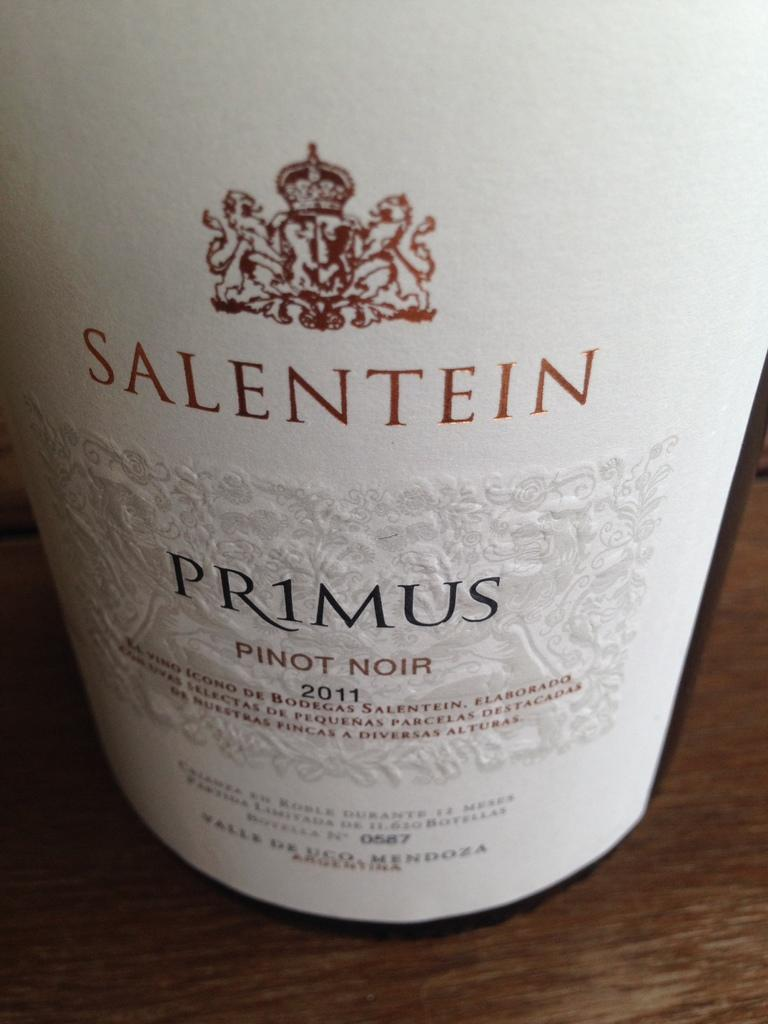<image>
Describe the image concisely. The bottle of Pinot Noir, from 2011, is white. 